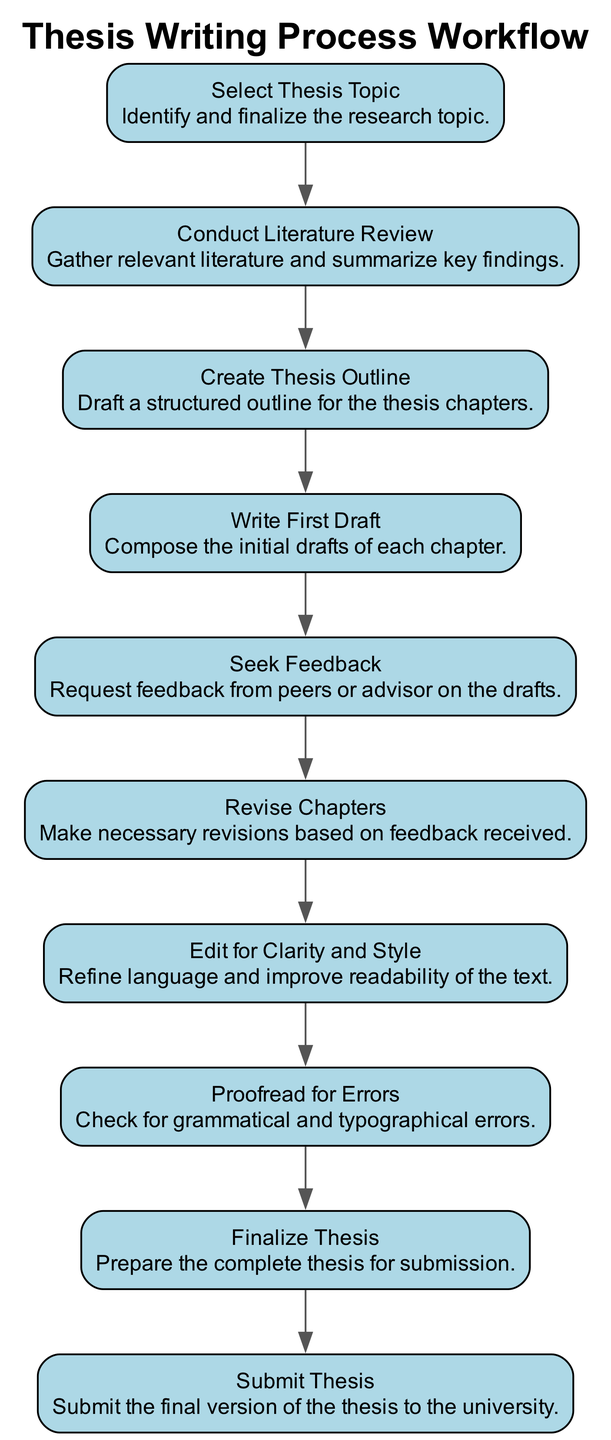What is the first step in the thesis writing process? The first step mentioned in the diagram is "Select Thesis Topic." This information is located at the beginning of the workflow sequence.
Answer: Select Thesis Topic How many steps are there in total? The diagram presents 10 steps in the writing process, each represented as a separate node. By counting all the process steps provided, we confirm the total number.
Answer: 10 What is the last step before finalizing the thesis? The last step before finalizing the thesis is "Proofread for Errors." It directly precedes the "Finalize Thesis" step in the flow.
Answer: Proofread for Errors Which step involves gathering literature? The step that involves gathering literature is "Conduct Literature Review." It can be identified as the second step in the sequence.
Answer: Conduct Literature Review What action is taken after writing the first draft? After writing the first draft, the action taken is to "Seek Feedback" from peers or advisors, which follows the writing stage in the workflow.
Answer: Seek Feedback How many steps involve the revision process? There are three steps that involve the revision process: "Seek Feedback," "Revise Chapters," and "Edit for Clarity and Style." These steps work together to improve the thesis drafts.
Answer: 3 Which step comes immediately after creating the thesis outline? The step that comes immediately after creating the thesis outline is "Write First Draft." This can be established by following the flow from the outline to the drafting stage.
Answer: Write First Draft What is required before finalizing the thesis? Before finalizing the thesis, the necessary step is to "Proofread for Errors," which ensures the text is free from mistakes.
Answer: Proofread for Errors Which two steps are connected directly, considering the feedback? The two steps connected directly considering the feedback are "Seek Feedback" and "Revise Chapters." The feedback helps inform the revisions made to the chapters.
Answer: Seek Feedback and Revise Chapters Which step is crucial for ensuring the readability of the text? The step crucial for ensuring the readability of the text is "Edit for Clarity and Style," focusing on language refinement and flow.
Answer: Edit for Clarity and Style 